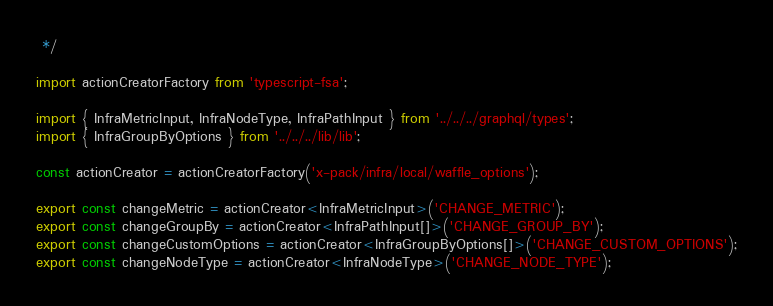<code> <loc_0><loc_0><loc_500><loc_500><_TypeScript_> */

import actionCreatorFactory from 'typescript-fsa';

import { InfraMetricInput, InfraNodeType, InfraPathInput } from '../../../graphql/types';
import { InfraGroupByOptions } from '../../../lib/lib';

const actionCreator = actionCreatorFactory('x-pack/infra/local/waffle_options');

export const changeMetric = actionCreator<InfraMetricInput>('CHANGE_METRIC');
export const changeGroupBy = actionCreator<InfraPathInput[]>('CHANGE_GROUP_BY');
export const changeCustomOptions = actionCreator<InfraGroupByOptions[]>('CHANGE_CUSTOM_OPTIONS');
export const changeNodeType = actionCreator<InfraNodeType>('CHANGE_NODE_TYPE');
</code> 